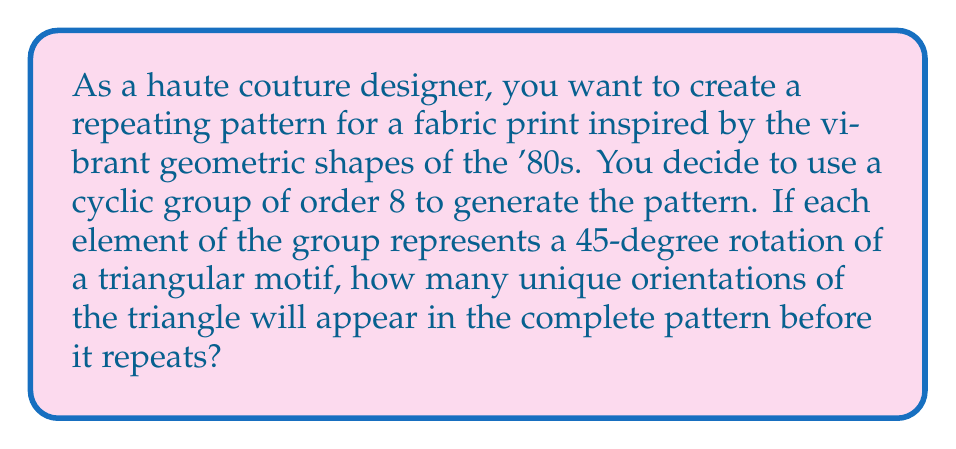Give your solution to this math problem. Let's approach this step-by-step:

1) First, let's consider the cyclic group of order 8, which we can denote as $C_8$. This group can be represented as:

   $C_8 = \{e, r, r^2, r^3, r^4, r^5, r^6, r^7\}$

   where $e$ is the identity element and $r$ represents a 45-degree rotation.

2) In this group, $r^8 = e$, meaning that after 8 rotations of 45 degrees each, we return to the starting position.

3) Each element of the group represents a unique orientation of the triangle:

   $e$: 0° rotation (original position)
   $r$: 45° rotation
   $r^2$: 90° rotation
   $r^3$: 135° rotation
   $r^4$: 180° rotation
   $r^5$: 225° rotation
   $r^6$: 270° rotation
   $r^7$: 315° rotation

4) The next element, $r^8$, would be equivalent to $e$, bringing us back to the starting position.

5) Therefore, the pattern will consist of 8 unique orientations of the triangle before it repeats.

This cyclic group structure ensures that the pattern will have a consistent, repeating nature, which is ideal for fabric prints. The 8 orientations provide enough variety to create an interesting design while maintaining a cohesive look, perfect for the bold, geometric styles characteristic of '80s fashion.
Answer: 8 unique orientations 